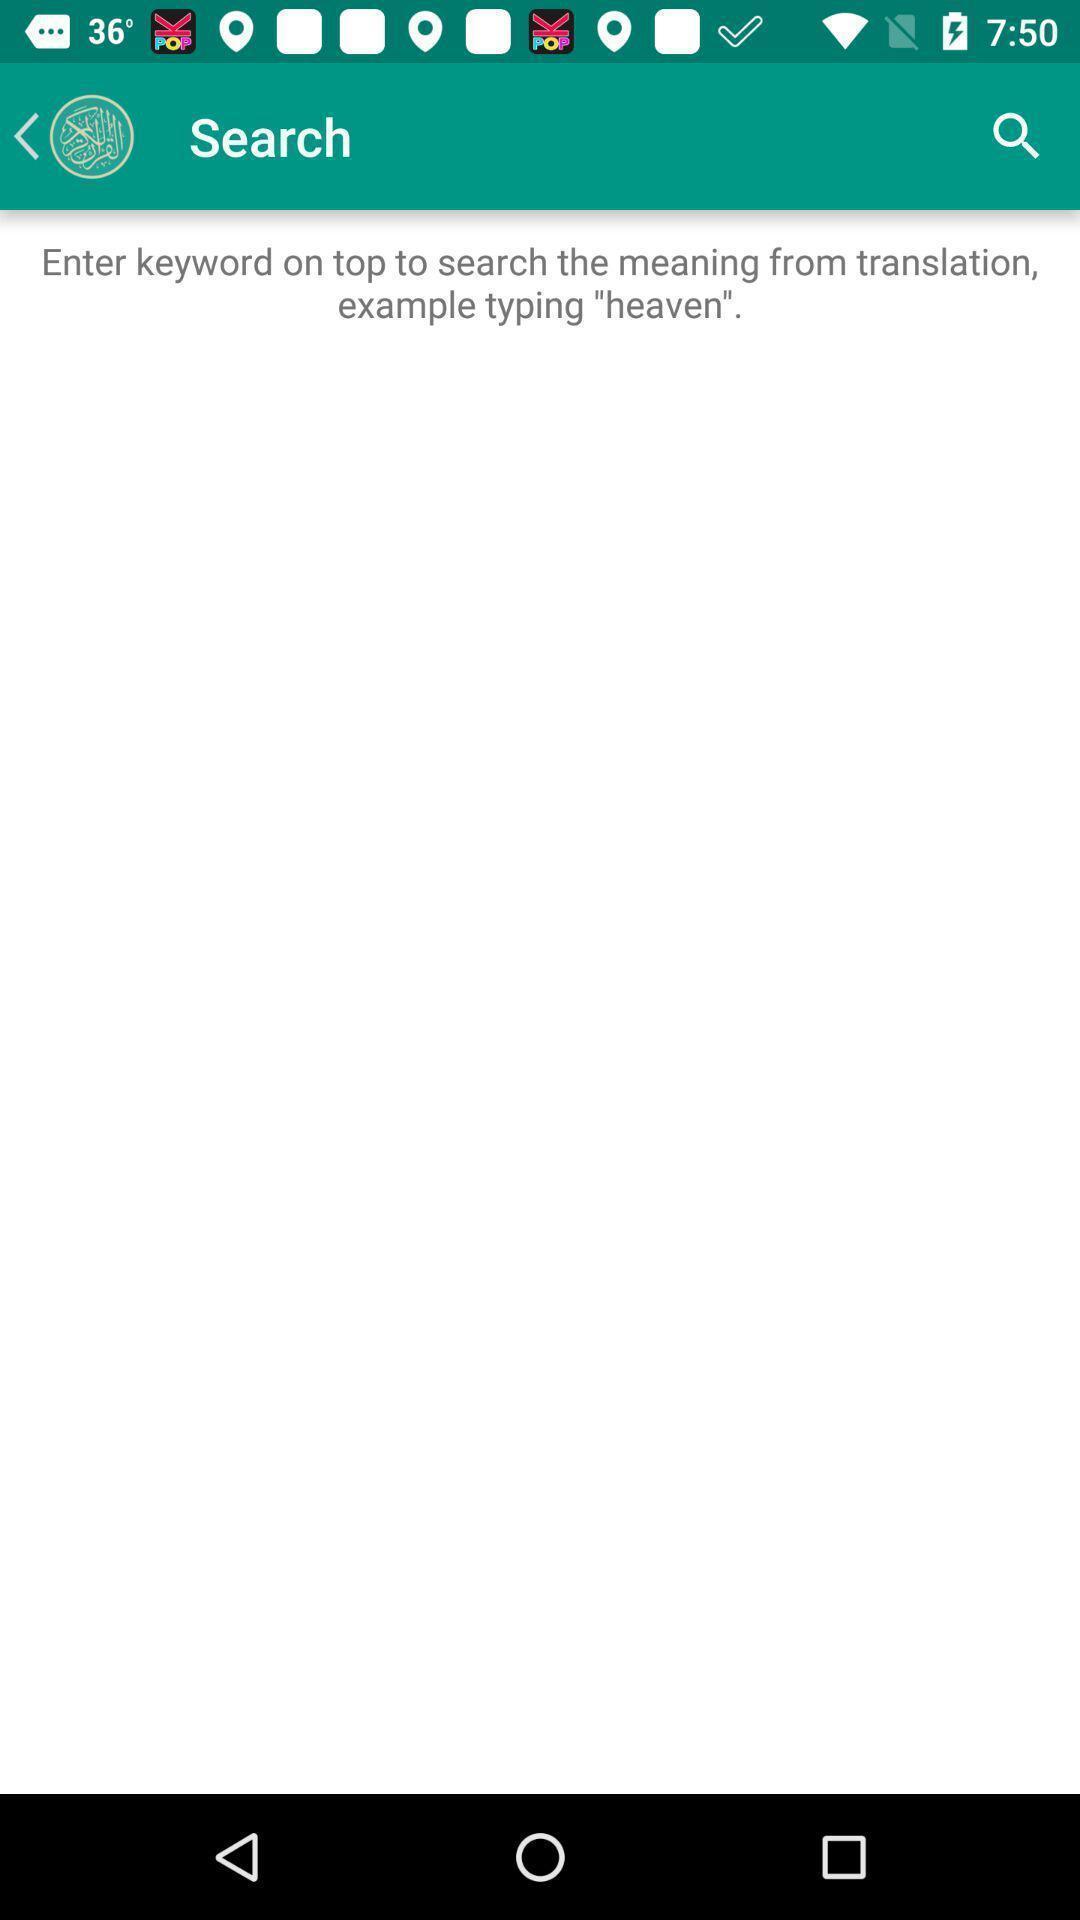What is the overall content of this screenshot? Search option showing in this page. 